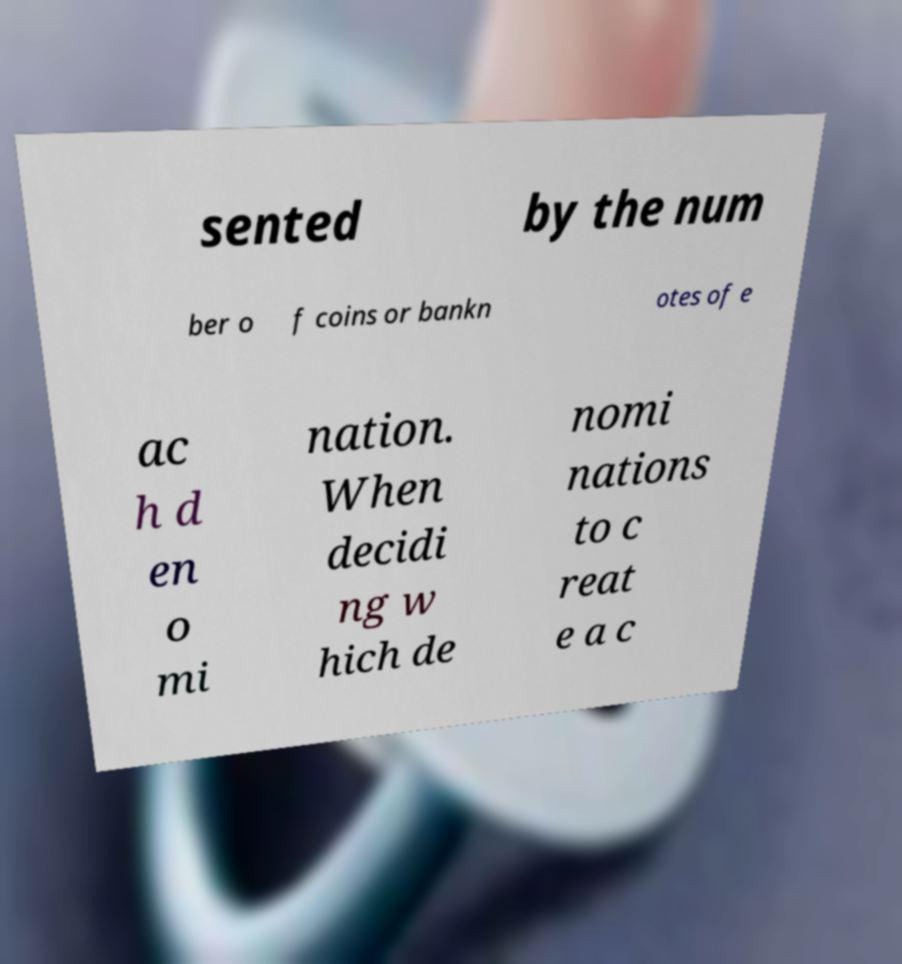Could you assist in decoding the text presented in this image and type it out clearly? sented by the num ber o f coins or bankn otes of e ac h d en o mi nation. When decidi ng w hich de nomi nations to c reat e a c 